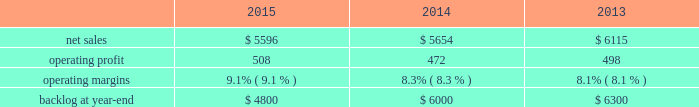Backlog backlog increased in 2015 compared to 2014 primarily due to higher orders on f-35 and c-130 programs .
Backlog decreased slightly in 2014 compared to 2013 primarily due to lower orders on f-16 and f-22 programs .
Trends we expect aeronautics 2019 2016 net sales to increase in the mid-single digit percentage range as compared to 2015 due to increased volume on the f-35 and c-130 programs , partially offset by decreased volume on the f-16 program .
Operating profit is also expected to increase in the low single-digit percentage range , driven by increased volume on the f-35 program offset by contract mix that results in a slight decrease in operating margins between years .
Information systems & global solutions our is&gs business segment provides advanced technology systems and expertise , integrated information technology solutions and management services across a broad spectrum of applications for civil , defense , intelligence and other government customers .
Is&gs 2019 technical services business provides a comprehensive portfolio of technical and sustainment services .
Is&gs has a portfolio of many smaller contracts as compared to our other business segments .
Is&gs has been impacted by the continued downturn in certain federal agencies 2019 information technology budgets and increased re-competition on existing contracts coupled with the fragmentation of large contracts into multiple smaller contracts that are awarded primarily on the basis of price .
Is&gs 2019 operating results included the following ( in millions ) : .
2015 compared to 2014 is&gs 2019 net sales decreased $ 58 million , or 1% ( 1 % ) , in 2015 as compared to 2014 .
The decrease was attributable to lower net sales of approximately $ 395 million as a result of key program completions , lower customer funding levels and increased competition , coupled with the fragmentation of existing large contracts into multiple smaller contracts that are awarded primarily on the basis of price when re-competed ( including cms-citic ) .
These decreases were partially offset by higher net sales of approximately $ 230 million for businesses acquired in 2014 ; and approximately $ 110 million due to the start-up of new programs and growth in recently awarded programs .
Is&gs 2019 operating profit increased $ 36 million , or 8% ( 8 % ) , in 2015 as compared to 2014 .
The increase was attributable to improved program performance and risk retirements , offset by decreased operating profit resulting from the activities mentioned above for net sales .
Adjustments not related to volume , including net profit booking rate adjustments and other matters , were approximately $ 70 million higher in 2015 compared to 2014 .
2014 compared to 2013 is&gs 2019 net sales decreased $ 461 million , or 8% ( 8 % ) , in 2014 as compared to 2013 .
The decrease was primarily attributable to lower net sales of about $ 475 million due to the wind-down or completion of certain programs , driven by reductions in direct warfighter support ( including jieddo ) ; and approximately $ 320 million due to decreased volume in technical services programs reflecting market pressures .
The decreases were offset by higher net sales of about $ 330 million due to the start-up of new programs , growth in recently awarded programs and integration of recently acquired companies .
Is&gs 2019 operating profit decreased $ 26 million , or 5% ( 5 % ) , in 2014 as compared to 2013 .
The decrease was primarily attributable to the activities mentioned above for sales , partially offset by severance recoveries related to the restructuring announced in november 2013 of approximately $ 20 million in 2014 .
Adjustments not related to volume , including net profit booking rate adjustments , were comparable in 2014 and 2013. .
What was the average operating margins for is&gs from 2013 to 2015? 
Computations: table_average(operating margins, none)
Answer: 0.085. 